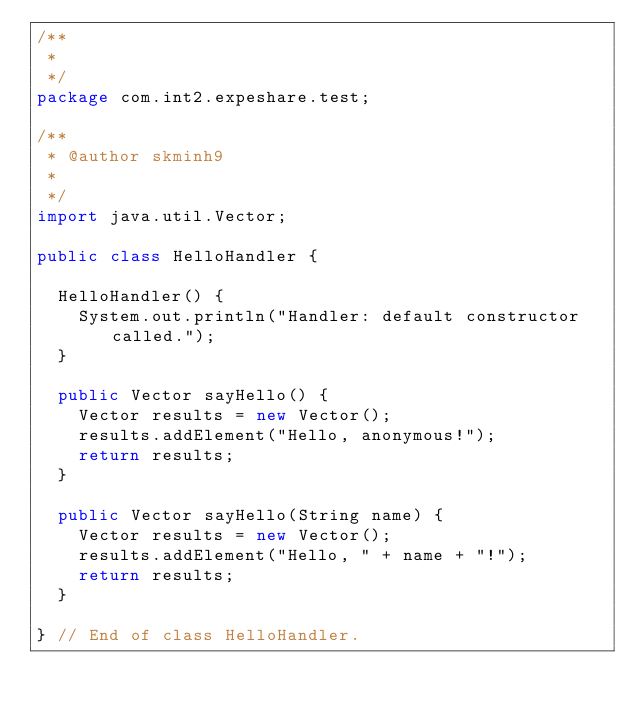Convert code to text. <code><loc_0><loc_0><loc_500><loc_500><_Java_>/**
 * 
 */
package com.int2.expeshare.test;

/**
 * @author skminh9
 *
 */
import java.util.Vector;

public class HelloHandler {

  HelloHandler() {
    System.out.println("Handler: default constructor called.");
  }
  
  public Vector sayHello() {
    Vector results = new Vector();
    results.addElement("Hello, anonymous!");
    return results;
  }

  public Vector sayHello(String name) {
    Vector results = new Vector();
    results.addElement("Hello, " + name + "!");
    return results;
  }

} // End of class HelloHandler.
</code> 